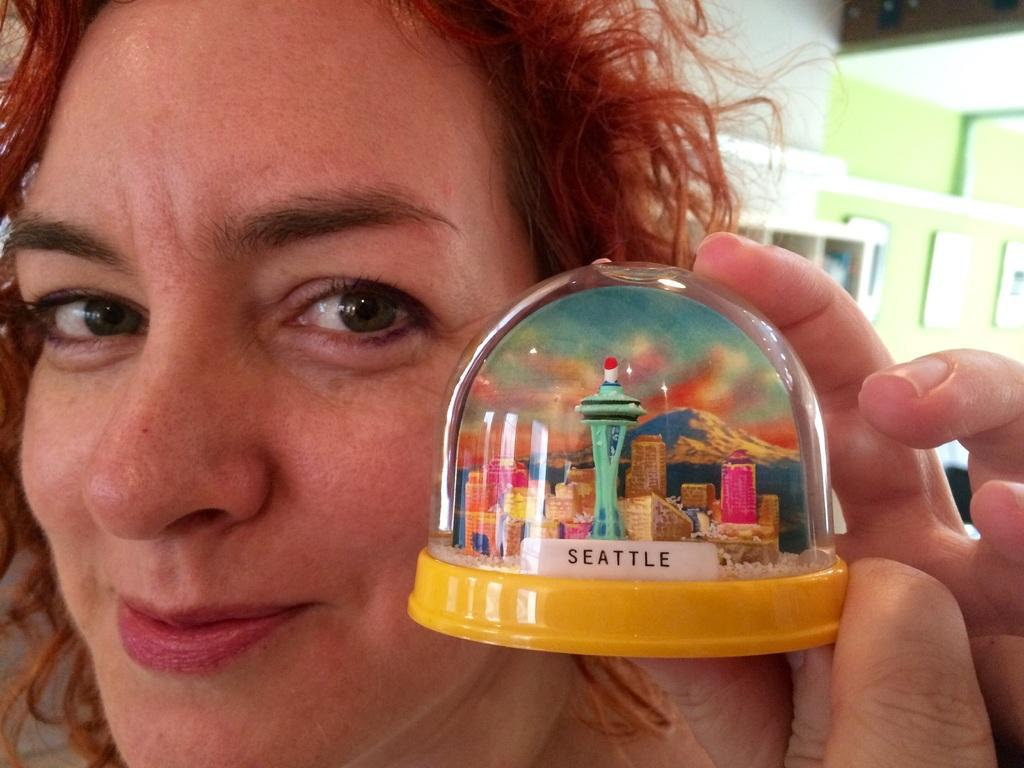Provide a one-sentence caption for the provided image. A redheaded woman is holding back a yellow-based Seattle snow globe. 